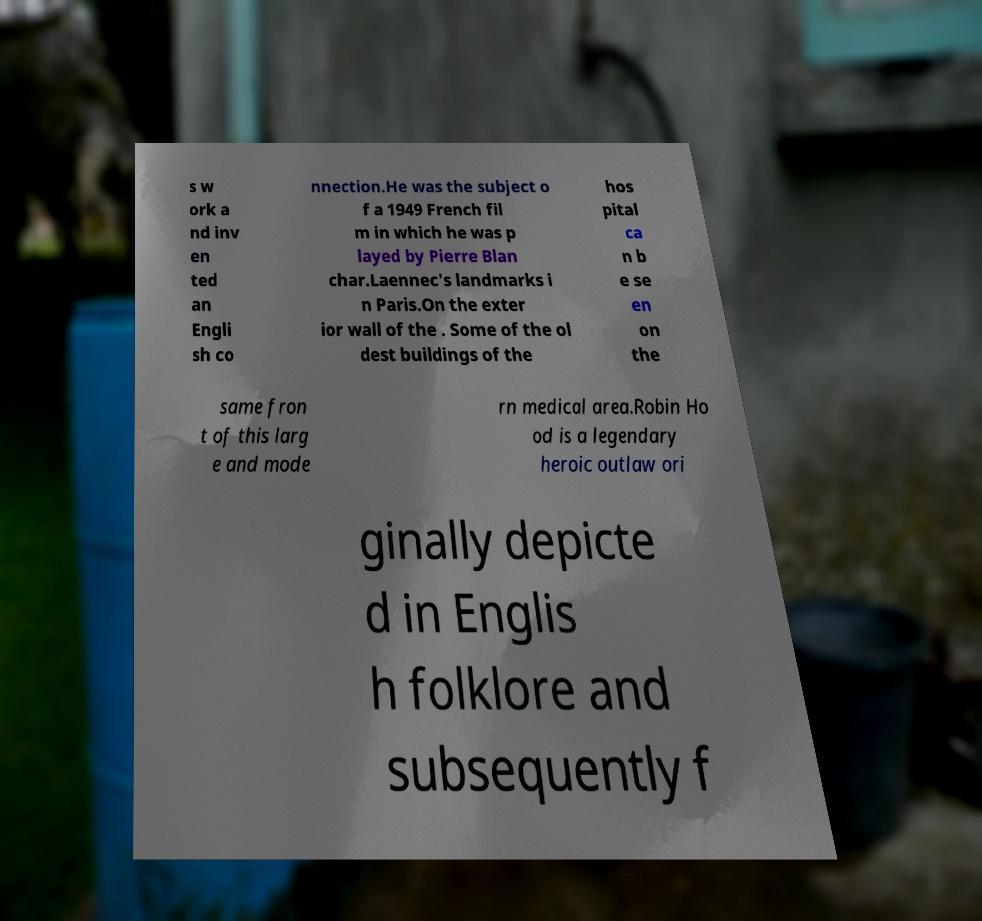For documentation purposes, I need the text within this image transcribed. Could you provide that? s w ork a nd inv en ted an Engli sh co nnection.He was the subject o f a 1949 French fil m in which he was p layed by Pierre Blan char.Laennec's landmarks i n Paris.On the exter ior wall of the . Some of the ol dest buildings of the hos pital ca n b e se en on the same fron t of this larg e and mode rn medical area.Robin Ho od is a legendary heroic outlaw ori ginally depicte d in Englis h folklore and subsequently f 